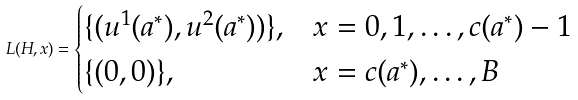<formula> <loc_0><loc_0><loc_500><loc_500>L ( H , x ) = \begin{cases} \{ ( u ^ { 1 } ( a ^ { * } ) , u ^ { 2 } ( a ^ { * } ) ) \} , & x = 0 , 1 , \dots , c ( a ^ { * } ) - 1 \\ \{ ( 0 , 0 ) \} , & x = c ( a ^ { * } ) , \dots , B \end{cases}</formula> 